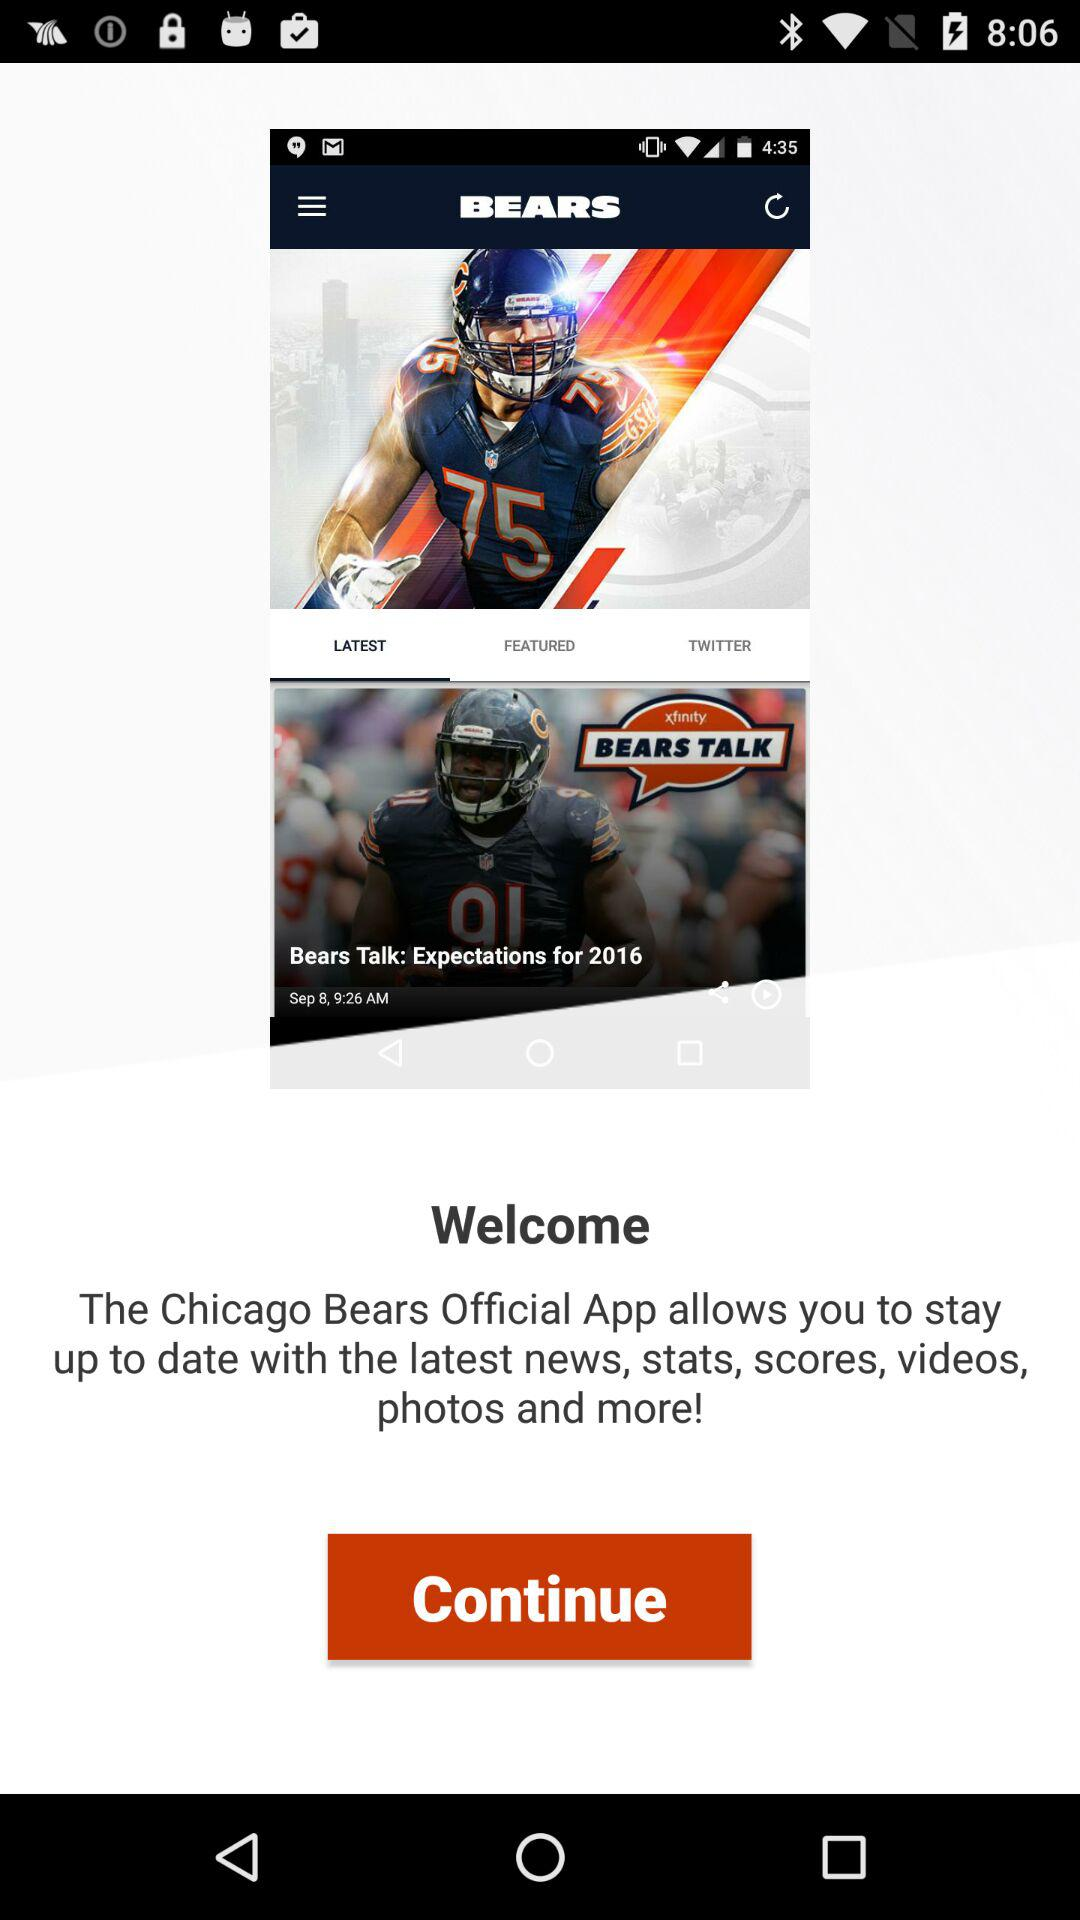What does the "Chicago Bears" application allow us? The "Chicago Bears" application allows you to stay up to date with the latest news, stats, scores, videos, photos and more. 